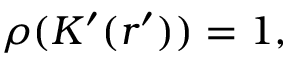<formula> <loc_0><loc_0><loc_500><loc_500>\rho ( K ^ { \prime } ( r ^ { \prime } ) ) = 1 ,</formula> 